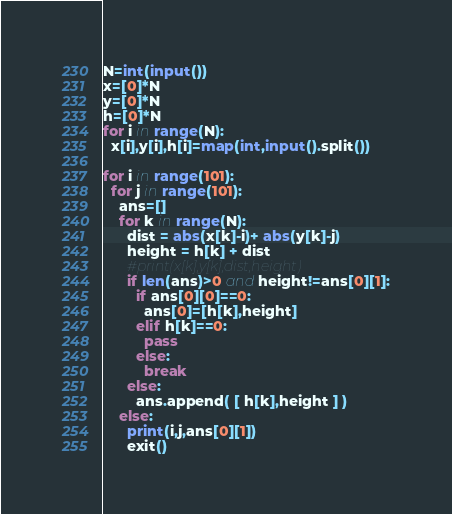<code> <loc_0><loc_0><loc_500><loc_500><_Python_>N=int(input())
x=[0]*N
y=[0]*N
h=[0]*N
for i in range(N):
  x[i],y[i],h[i]=map(int,input().split())

for i in range(101):
  for j in range(101):
    ans=[]
    for k in range(N):
      dist = abs(x[k]-i)+ abs(y[k]-j)
      height = h[k] + dist
      #print(x[k],y[k],dist,height)
      if len(ans)>0 and height!=ans[0][1]:
        if ans[0][0]==0:
          ans[0]=[h[k],height]
        elif h[k]==0:
          pass
        else:
          break
      else:
        ans.append( [ h[k],height ] ) 
    else:
      print(i,j,ans[0][1])
      exit()</code> 